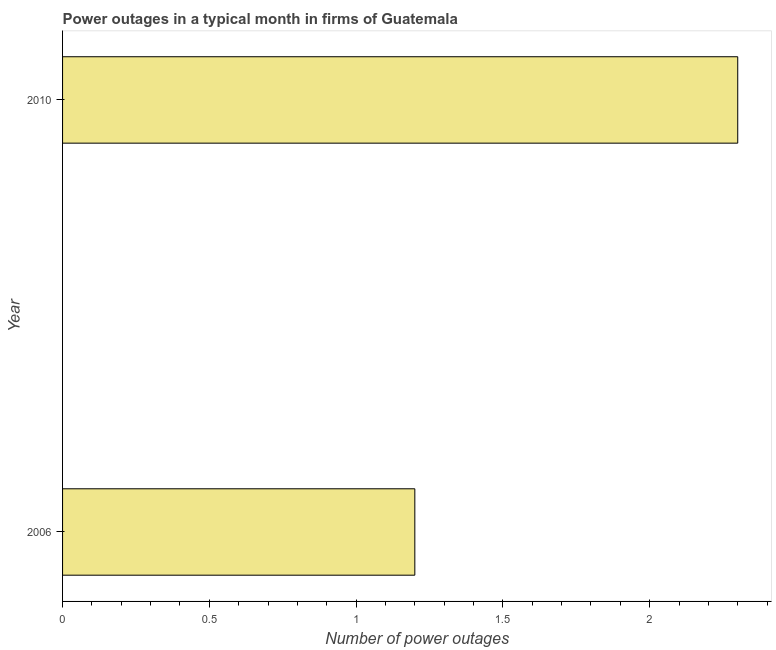Does the graph contain grids?
Give a very brief answer. No. What is the title of the graph?
Give a very brief answer. Power outages in a typical month in firms of Guatemala. What is the label or title of the X-axis?
Provide a succinct answer. Number of power outages. What is the label or title of the Y-axis?
Keep it short and to the point. Year. Across all years, what is the maximum number of power outages?
Your response must be concise. 2.3. Across all years, what is the minimum number of power outages?
Provide a succinct answer. 1.2. In which year was the number of power outages minimum?
Provide a short and direct response. 2006. What is the median number of power outages?
Your answer should be very brief. 1.75. In how many years, is the number of power outages greater than 1 ?
Your response must be concise. 2. What is the ratio of the number of power outages in 2006 to that in 2010?
Offer a terse response. 0.52. Is the number of power outages in 2006 less than that in 2010?
Ensure brevity in your answer.  Yes. In how many years, is the number of power outages greater than the average number of power outages taken over all years?
Keep it short and to the point. 1. How many bars are there?
Offer a terse response. 2. Are all the bars in the graph horizontal?
Give a very brief answer. Yes. How many years are there in the graph?
Provide a succinct answer. 2. Are the values on the major ticks of X-axis written in scientific E-notation?
Offer a very short reply. No. What is the Number of power outages in 2006?
Make the answer very short. 1.2. What is the Number of power outages in 2010?
Keep it short and to the point. 2.3. What is the difference between the Number of power outages in 2006 and 2010?
Make the answer very short. -1.1. What is the ratio of the Number of power outages in 2006 to that in 2010?
Ensure brevity in your answer.  0.52. 